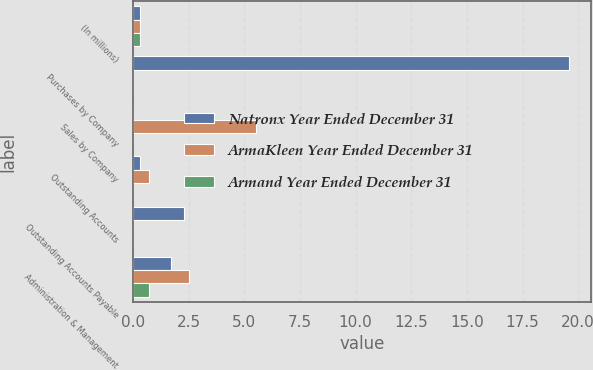Convert chart to OTSL. <chart><loc_0><loc_0><loc_500><loc_500><stacked_bar_chart><ecel><fcel>(In millions)<fcel>Purchases by Company<fcel>Sales by Company<fcel>Outstanding Accounts<fcel>Outstanding Accounts Payable<fcel>Administration & Management<nl><fcel>Natronx Year Ended December 31<fcel>0.3<fcel>19.6<fcel>0<fcel>0.3<fcel>2.3<fcel>1.7<nl><fcel>ArmaKleen Year Ended December 31<fcel>0.3<fcel>0<fcel>5.5<fcel>0.7<fcel>0<fcel>2.5<nl><fcel>Armand Year Ended December 31<fcel>0.3<fcel>0<fcel>0<fcel>0<fcel>0<fcel>0.7<nl></chart> 